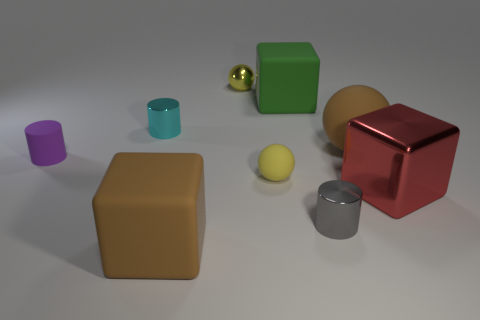How many other things are there of the same color as the big rubber sphere?
Provide a succinct answer. 1. How many other green things are the same shape as the green matte object?
Make the answer very short. 0. What is the material of the big block to the right of the small gray shiny cylinder?
Provide a short and direct response. Metal. Are there fewer big brown rubber cubes behind the big green rubber block than large red objects?
Keep it short and to the point. Yes. Is the shape of the yellow matte object the same as the yellow metallic thing?
Your answer should be compact. Yes. Are there any other things that are the same shape as the big green object?
Offer a terse response. Yes. Are any big brown matte cubes visible?
Give a very brief answer. Yes. There is a tiny yellow shiny object; is its shape the same as the brown matte thing that is behind the yellow rubber thing?
Your response must be concise. Yes. What material is the large brown thing that is behind the brown thing on the left side of the yellow metal ball made of?
Make the answer very short. Rubber. The big shiny thing has what color?
Your answer should be very brief. Red. 